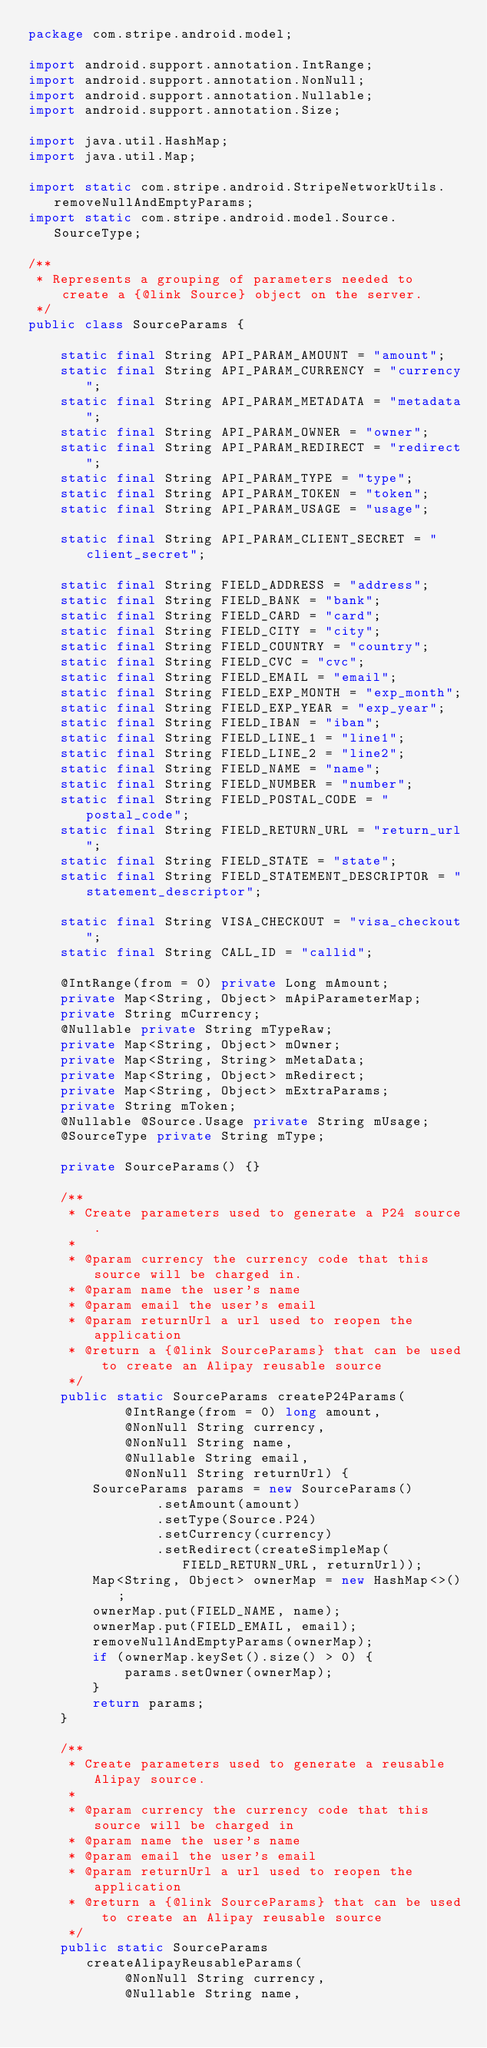<code> <loc_0><loc_0><loc_500><loc_500><_Java_>package com.stripe.android.model;

import android.support.annotation.IntRange;
import android.support.annotation.NonNull;
import android.support.annotation.Nullable;
import android.support.annotation.Size;

import java.util.HashMap;
import java.util.Map;

import static com.stripe.android.StripeNetworkUtils.removeNullAndEmptyParams;
import static com.stripe.android.model.Source.SourceType;

/**
 * Represents a grouping of parameters needed to create a {@link Source} object on the server.
 */
public class SourceParams {

    static final String API_PARAM_AMOUNT = "amount";
    static final String API_PARAM_CURRENCY = "currency";
    static final String API_PARAM_METADATA = "metadata";
    static final String API_PARAM_OWNER = "owner";
    static final String API_PARAM_REDIRECT = "redirect";
    static final String API_PARAM_TYPE = "type";
    static final String API_PARAM_TOKEN = "token";
    static final String API_PARAM_USAGE = "usage";

    static final String API_PARAM_CLIENT_SECRET = "client_secret";

    static final String FIELD_ADDRESS = "address";
    static final String FIELD_BANK = "bank";
    static final String FIELD_CARD = "card";
    static final String FIELD_CITY = "city";
    static final String FIELD_COUNTRY = "country";
    static final String FIELD_CVC = "cvc";
    static final String FIELD_EMAIL = "email";
    static final String FIELD_EXP_MONTH = "exp_month";
    static final String FIELD_EXP_YEAR = "exp_year";
    static final String FIELD_IBAN = "iban";
    static final String FIELD_LINE_1 = "line1";
    static final String FIELD_LINE_2 = "line2";
    static final String FIELD_NAME = "name";
    static final String FIELD_NUMBER = "number";
    static final String FIELD_POSTAL_CODE = "postal_code";
    static final String FIELD_RETURN_URL = "return_url";
    static final String FIELD_STATE = "state";
    static final String FIELD_STATEMENT_DESCRIPTOR = "statement_descriptor";

    static final String VISA_CHECKOUT = "visa_checkout";
    static final String CALL_ID = "callid";

    @IntRange(from = 0) private Long mAmount;
    private Map<String, Object> mApiParameterMap;
    private String mCurrency;
    @Nullable private String mTypeRaw;
    private Map<String, Object> mOwner;
    private Map<String, String> mMetaData;
    private Map<String, Object> mRedirect;
    private Map<String, Object> mExtraParams;
    private String mToken;
    @Nullable @Source.Usage private String mUsage;
    @SourceType private String mType;

    private SourceParams() {}

    /**
     * Create parameters used to generate a P24 source.
     *
     * @param currency the currency code that this source will be charged in.
     * @param name the user's name
     * @param email the user's email
     * @param returnUrl a url used to reopen the application
     * @return a {@link SourceParams} that can be used to create an Alipay reusable source
     */
    public static SourceParams createP24Params(
            @IntRange(from = 0) long amount,
            @NonNull String currency,
            @NonNull String name,
            @Nullable String email,
            @NonNull String returnUrl) {
        SourceParams params = new SourceParams()
                .setAmount(amount)
                .setType(Source.P24)
                .setCurrency(currency)
                .setRedirect(createSimpleMap(FIELD_RETURN_URL, returnUrl));
        Map<String, Object> ownerMap = new HashMap<>();
        ownerMap.put(FIELD_NAME, name);
        ownerMap.put(FIELD_EMAIL, email);
        removeNullAndEmptyParams(ownerMap);
        if (ownerMap.keySet().size() > 0) {
            params.setOwner(ownerMap);
        }
        return params;
    }

    /**
     * Create parameters used to generate a reusable Alipay source.
     *
     * @param currency the currency code that this source will be charged in
     * @param name the user's name
     * @param email the user's email
     * @param returnUrl a url used to reopen the application
     * @return a {@link SourceParams} that can be used to create an Alipay reusable source
     */
    public static SourceParams createAlipayReusableParams(
            @NonNull String currency,
            @Nullable String name,</code> 